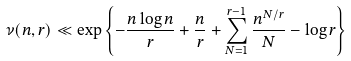<formula> <loc_0><loc_0><loc_500><loc_500>\nu ( n , r ) & \ll \exp \left \{ - \frac { n \log n } { r } + \frac { n } { r } + \sum _ { N = 1 } ^ { r - 1 } \frac { n ^ { N / r } } { N } - \log r \right \}</formula> 